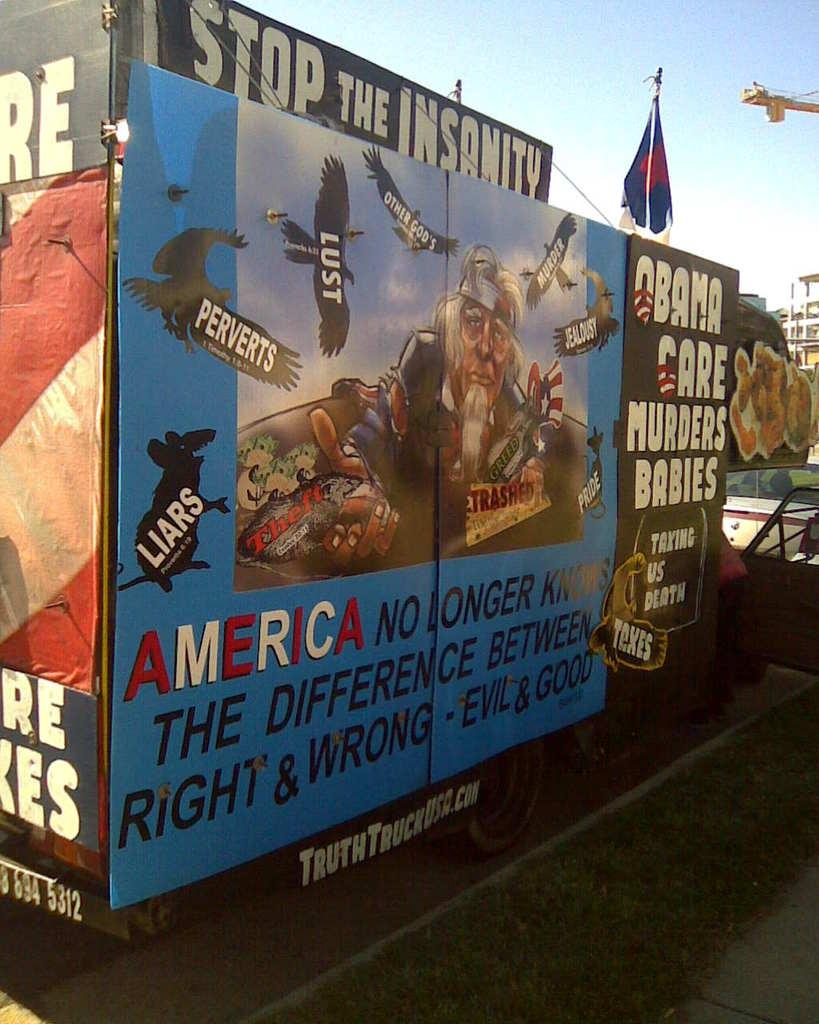<image>
Create a compact narrative representing the image presented. A billboard says that America no longer knows the difference between right and wrong. 